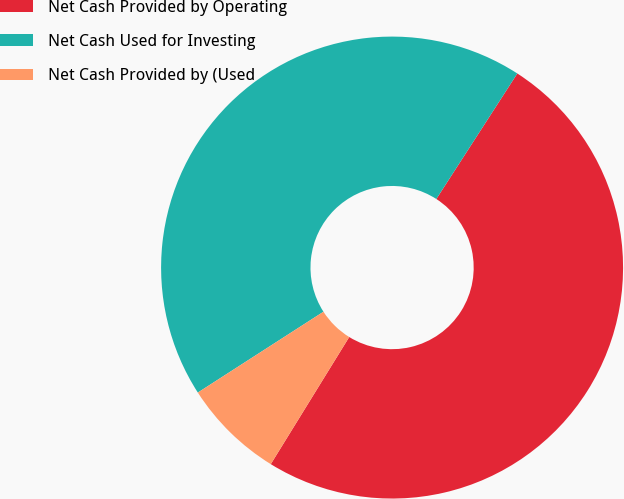<chart> <loc_0><loc_0><loc_500><loc_500><pie_chart><fcel>Net Cash Provided by Operating<fcel>Net Cash Used for Investing<fcel>Net Cash Provided by (Used<nl><fcel>49.68%<fcel>43.22%<fcel>7.1%<nl></chart> 